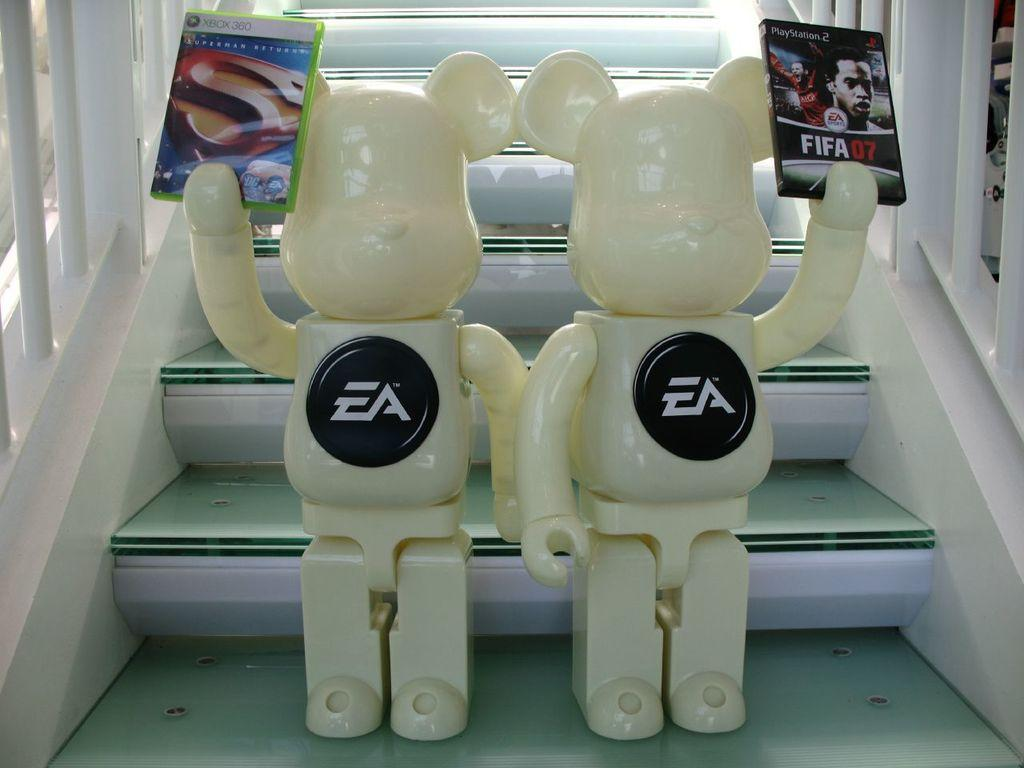What objects are present in the image? There are two toys in the image. What are the toys holding in their hands? The toys are holding books in their hands. Where are the toys positioned in the image? The toys are standing on the stairs. Reasoning: Let's think step by step by step in order to produce the conversation. We start by identifying the main subjects in the image, which are the two toys. Then, we describe what the toys are doing, which is holding books in their hands. Finally, we mention the location of the toys, which is on the stairs. Each question is designed to create the conversation. We avoid yes/no questions and ensure that the language is simple and clear. Absurd Question/Answer: What type of throne is the boy sitting on in the image? There is no boy or throne present in the image; it features two toys holding books and standing on the stairs. What type of coat is the boy wearing in the image? There is no boy or coat present in the image; it features two toys holding books and standing on the stairs. 